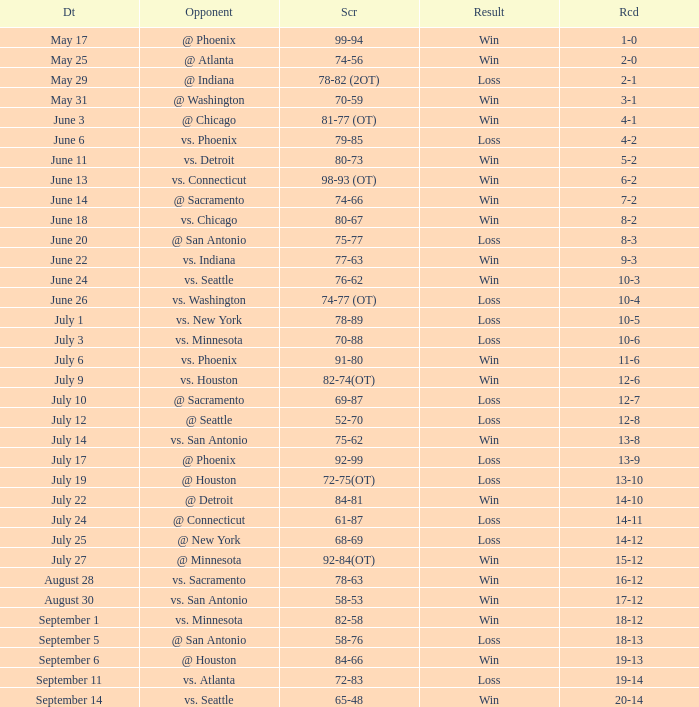What is the Opponent of the game with a Score of 74-66? @ Sacramento. 